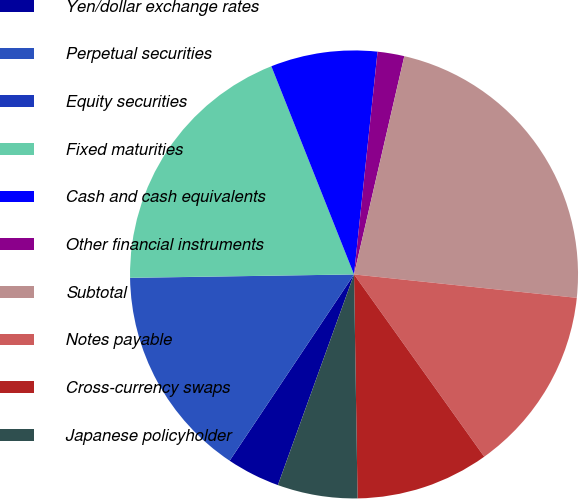<chart> <loc_0><loc_0><loc_500><loc_500><pie_chart><fcel>Yen/dollar exchange rates<fcel>Perpetual securities<fcel>Equity securities<fcel>Fixed maturities<fcel>Cash and cash equivalents<fcel>Other financial instruments<fcel>Subtotal<fcel>Notes payable<fcel>Cross-currency swaps<fcel>Japanese policyholder<nl><fcel>3.85%<fcel>15.38%<fcel>0.01%<fcel>19.22%<fcel>7.69%<fcel>1.93%<fcel>23.06%<fcel>13.46%<fcel>9.62%<fcel>5.77%<nl></chart> 